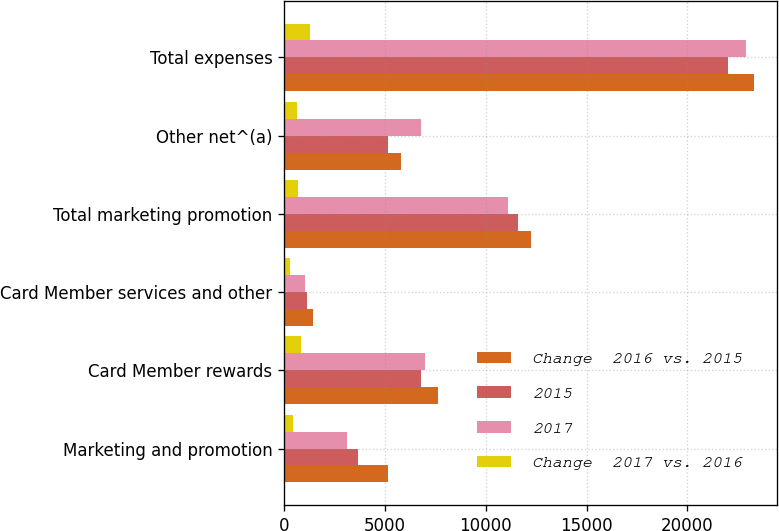Convert chart. <chart><loc_0><loc_0><loc_500><loc_500><stacked_bar_chart><ecel><fcel>Marketing and promotion<fcel>Card Member rewards<fcel>Card Member services and other<fcel>Total marketing promotion<fcel>Other net^(a)<fcel>Total expenses<nl><fcel>Change  2016 vs. 2015<fcel>5162<fcel>7608<fcel>1439<fcel>12264<fcel>5776<fcel>23298<nl><fcel>2015<fcel>3650<fcel>6793<fcel>1133<fcel>11576<fcel>5162<fcel>21997<nl><fcel>2017<fcel>3109<fcel>6996<fcel>1018<fcel>11123<fcel>6793<fcel>22892<nl><fcel>Change  2017 vs. 2016<fcel>433<fcel>815<fcel>306<fcel>688<fcel>614<fcel>1301<nl></chart> 